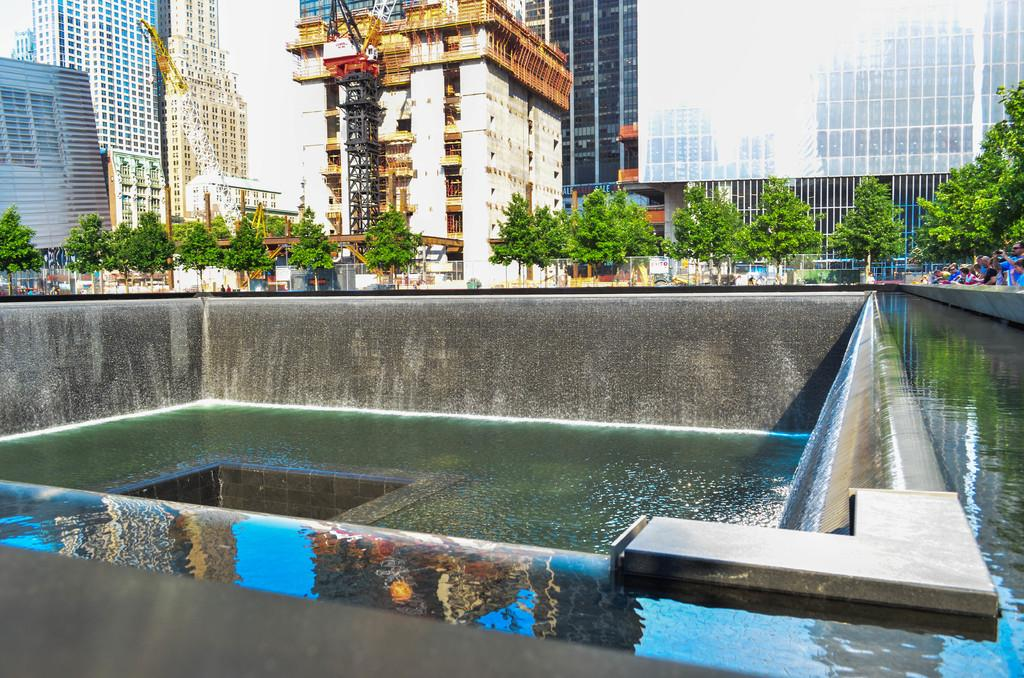What type of view is shown in the image? The image is an outside view. What is located at the bottom of the image? There is a fountain at the bottom of the image. What can be seen in the background of the image? There are many trees and buildings in the background of the image. Are there any people visible in the image? Yes, there are a few people on the right side of the image. What type of book is being read by the person in jail in the image? There is no person in jail or book present in the image. What kind of boot is visible on the left side of the image? There is no boot visible on the left side of the image. 